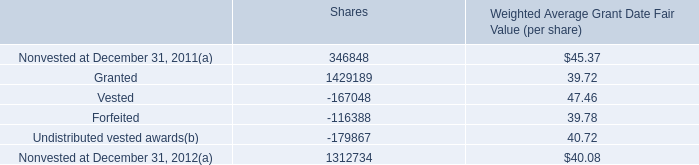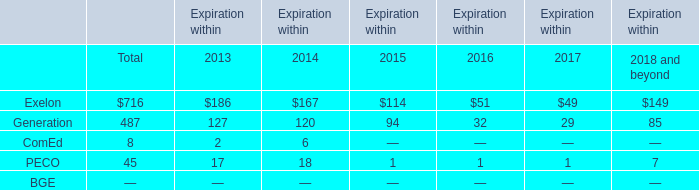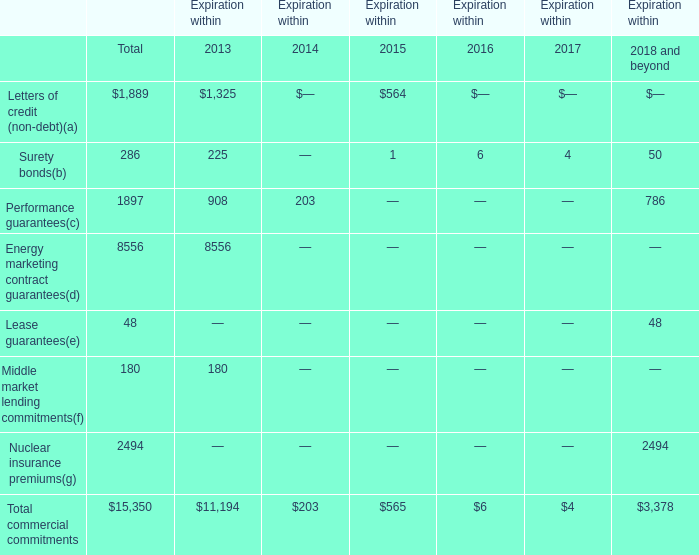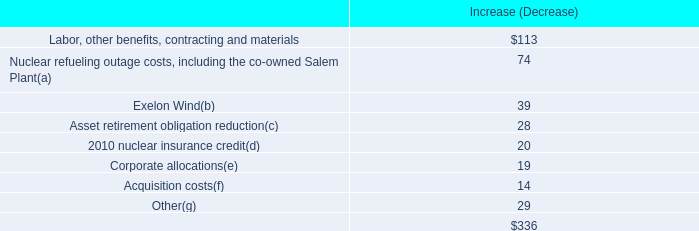What is the growing rate of ComEd in the year with the most PECO? 
Computations: ((6 - 2) / 2)
Answer: 2.0. 